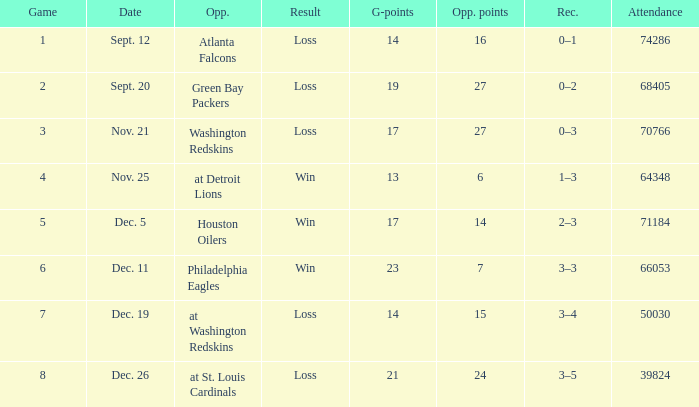What is the record when the opponent is washington redskins? 0–3. 